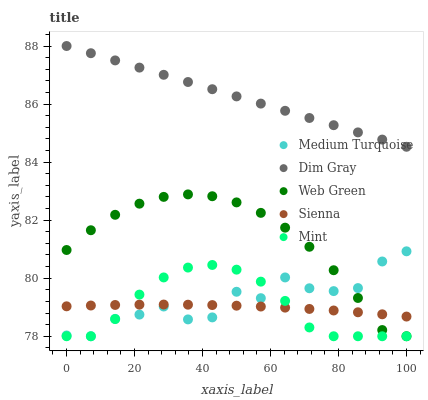Does Sienna have the minimum area under the curve?
Answer yes or no. Yes. Does Dim Gray have the maximum area under the curve?
Answer yes or no. Yes. Does Mint have the minimum area under the curve?
Answer yes or no. No. Does Mint have the maximum area under the curve?
Answer yes or no. No. Is Dim Gray the smoothest?
Answer yes or no. Yes. Is Medium Turquoise the roughest?
Answer yes or no. Yes. Is Mint the smoothest?
Answer yes or no. No. Is Mint the roughest?
Answer yes or no. No. Does Mint have the lowest value?
Answer yes or no. Yes. Does Dim Gray have the lowest value?
Answer yes or no. No. Does Dim Gray have the highest value?
Answer yes or no. Yes. Does Mint have the highest value?
Answer yes or no. No. Is Sienna less than Dim Gray?
Answer yes or no. Yes. Is Dim Gray greater than Medium Turquoise?
Answer yes or no. Yes. Does Sienna intersect Web Green?
Answer yes or no. Yes. Is Sienna less than Web Green?
Answer yes or no. No. Is Sienna greater than Web Green?
Answer yes or no. No. Does Sienna intersect Dim Gray?
Answer yes or no. No. 